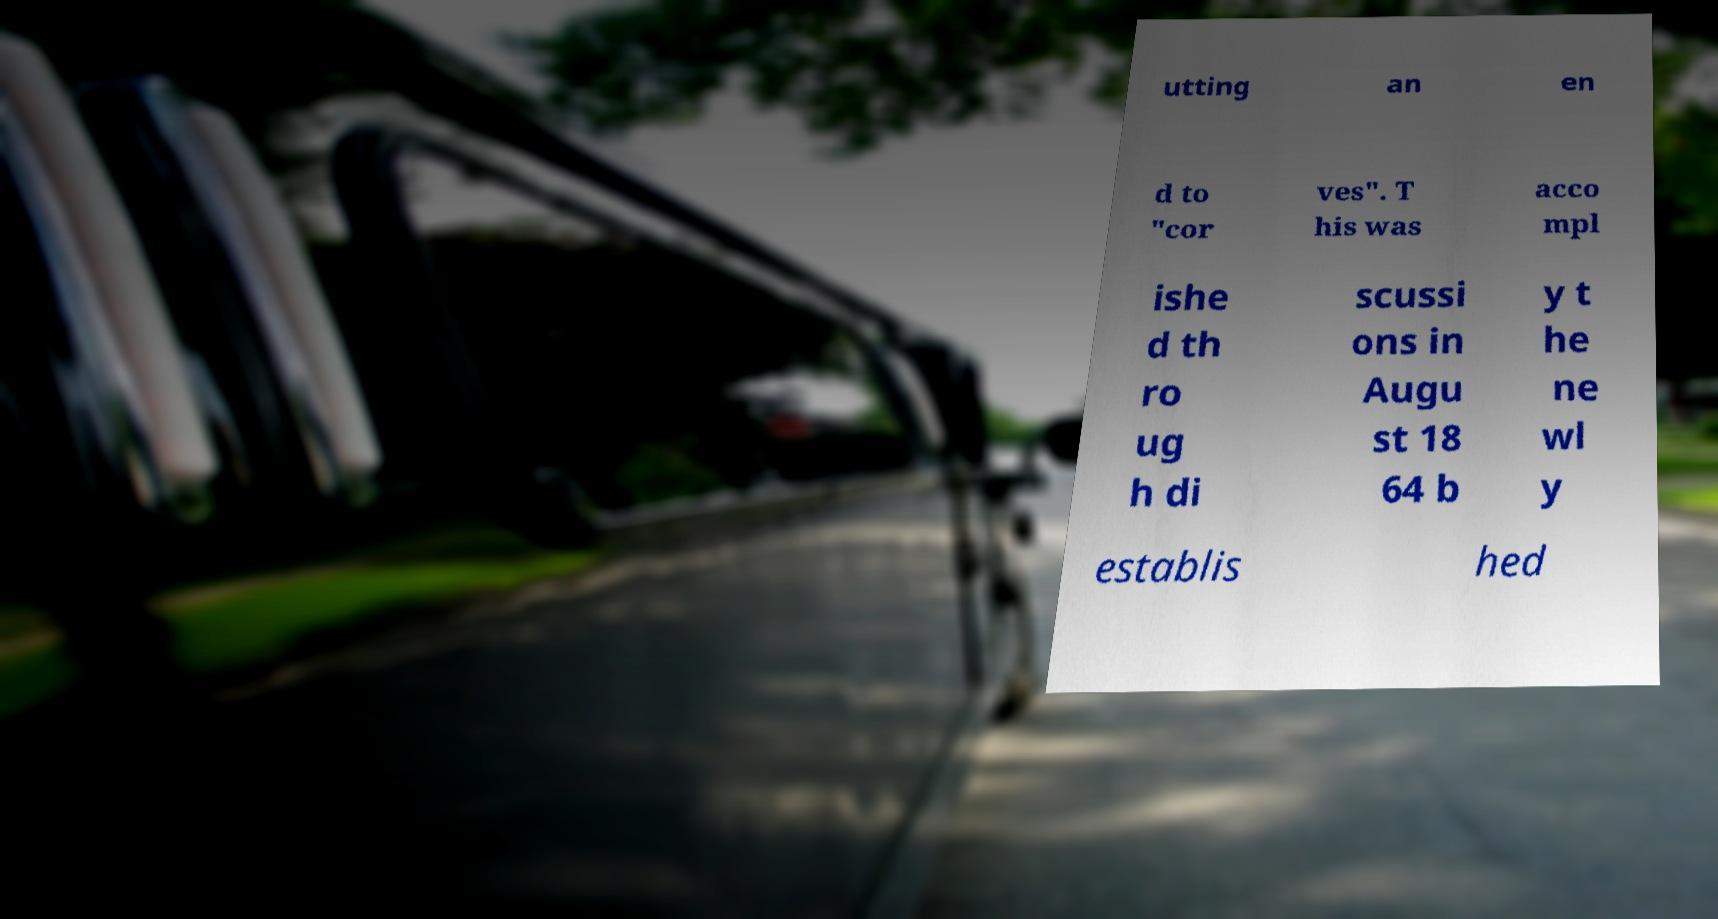For documentation purposes, I need the text within this image transcribed. Could you provide that? utting an en d to "cor ves". T his was acco mpl ishe d th ro ug h di scussi ons in Augu st 18 64 b y t he ne wl y establis hed 